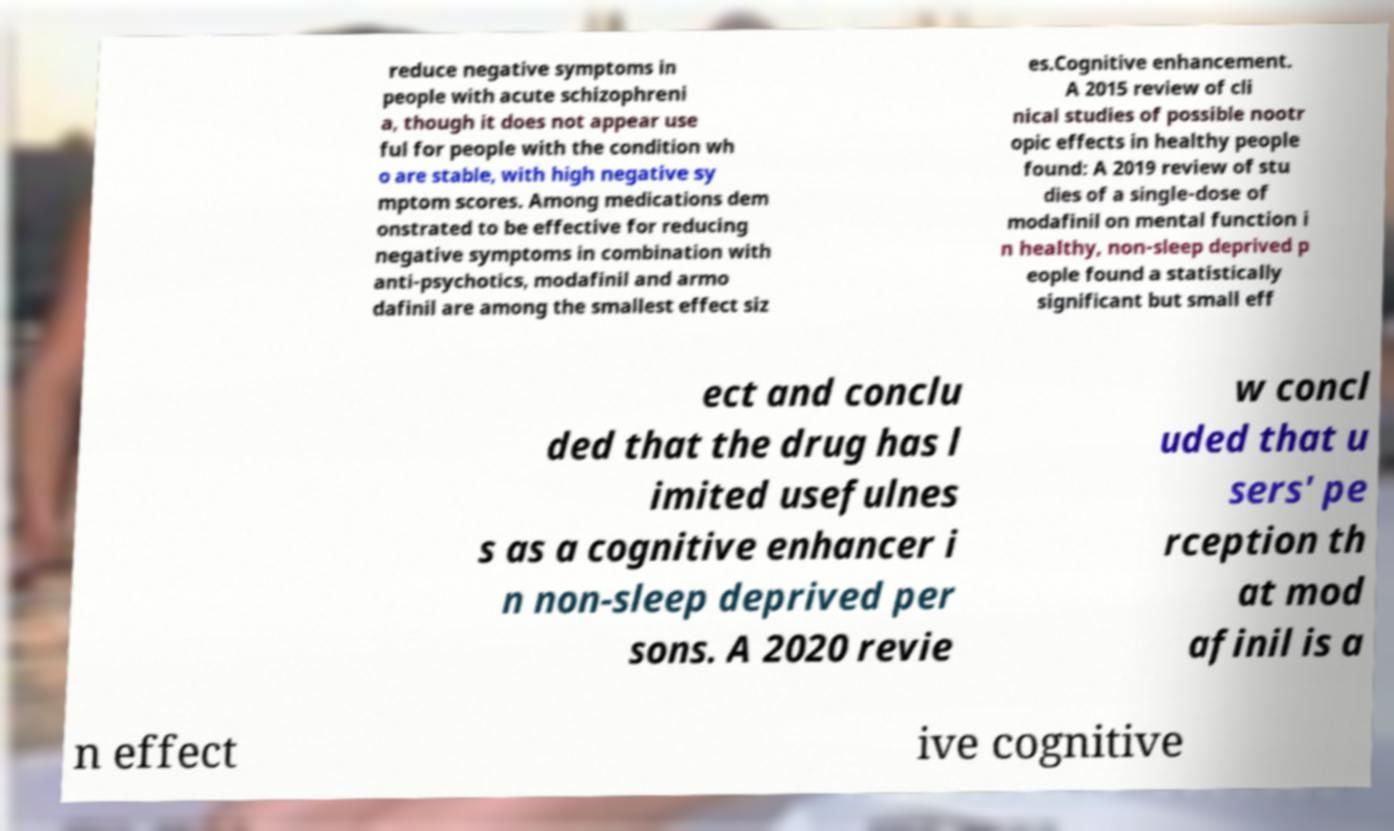Please read and relay the text visible in this image. What does it say? reduce negative symptoms in people with acute schizophreni a, though it does not appear use ful for people with the condition wh o are stable, with high negative sy mptom scores. Among medications dem onstrated to be effective for reducing negative symptoms in combination with anti-psychotics, modafinil and armo dafinil are among the smallest effect siz es.Cognitive enhancement. A 2015 review of cli nical studies of possible nootr opic effects in healthy people found: A 2019 review of stu dies of a single-dose of modafinil on mental function i n healthy, non-sleep deprived p eople found a statistically significant but small eff ect and conclu ded that the drug has l imited usefulnes s as a cognitive enhancer i n non-sleep deprived per sons. A 2020 revie w concl uded that u sers' pe rception th at mod afinil is a n effect ive cognitive 